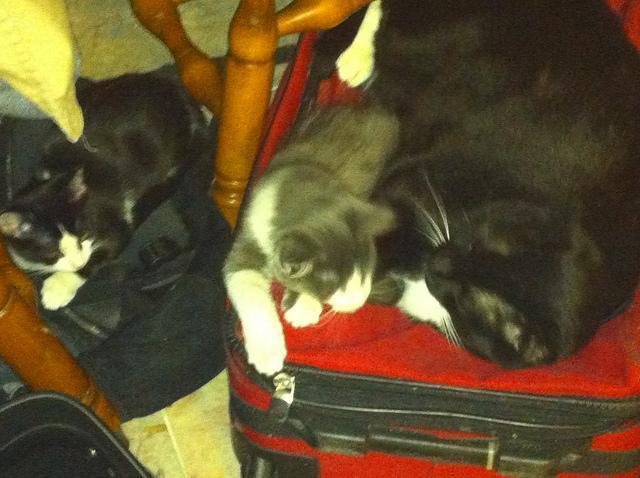How many cats?
Give a very brief answer. 3. How many cats can you see?
Give a very brief answer. 3. How many chairs are visible?
Give a very brief answer. 2. How many train track junctions can be seen?
Give a very brief answer. 0. 